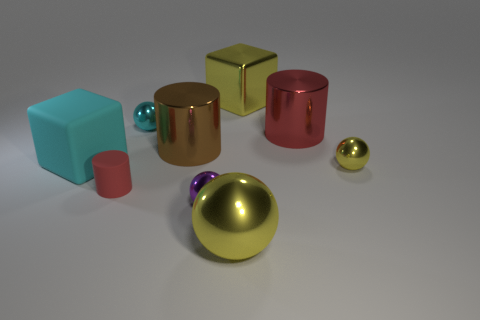Subtract all blocks. How many objects are left? 7 Add 1 tiny cyan cylinders. How many tiny cyan cylinders exist? 1 Subtract 1 brown cylinders. How many objects are left? 8 Subtract all red matte objects. Subtract all red rubber things. How many objects are left? 7 Add 6 matte objects. How many matte objects are left? 8 